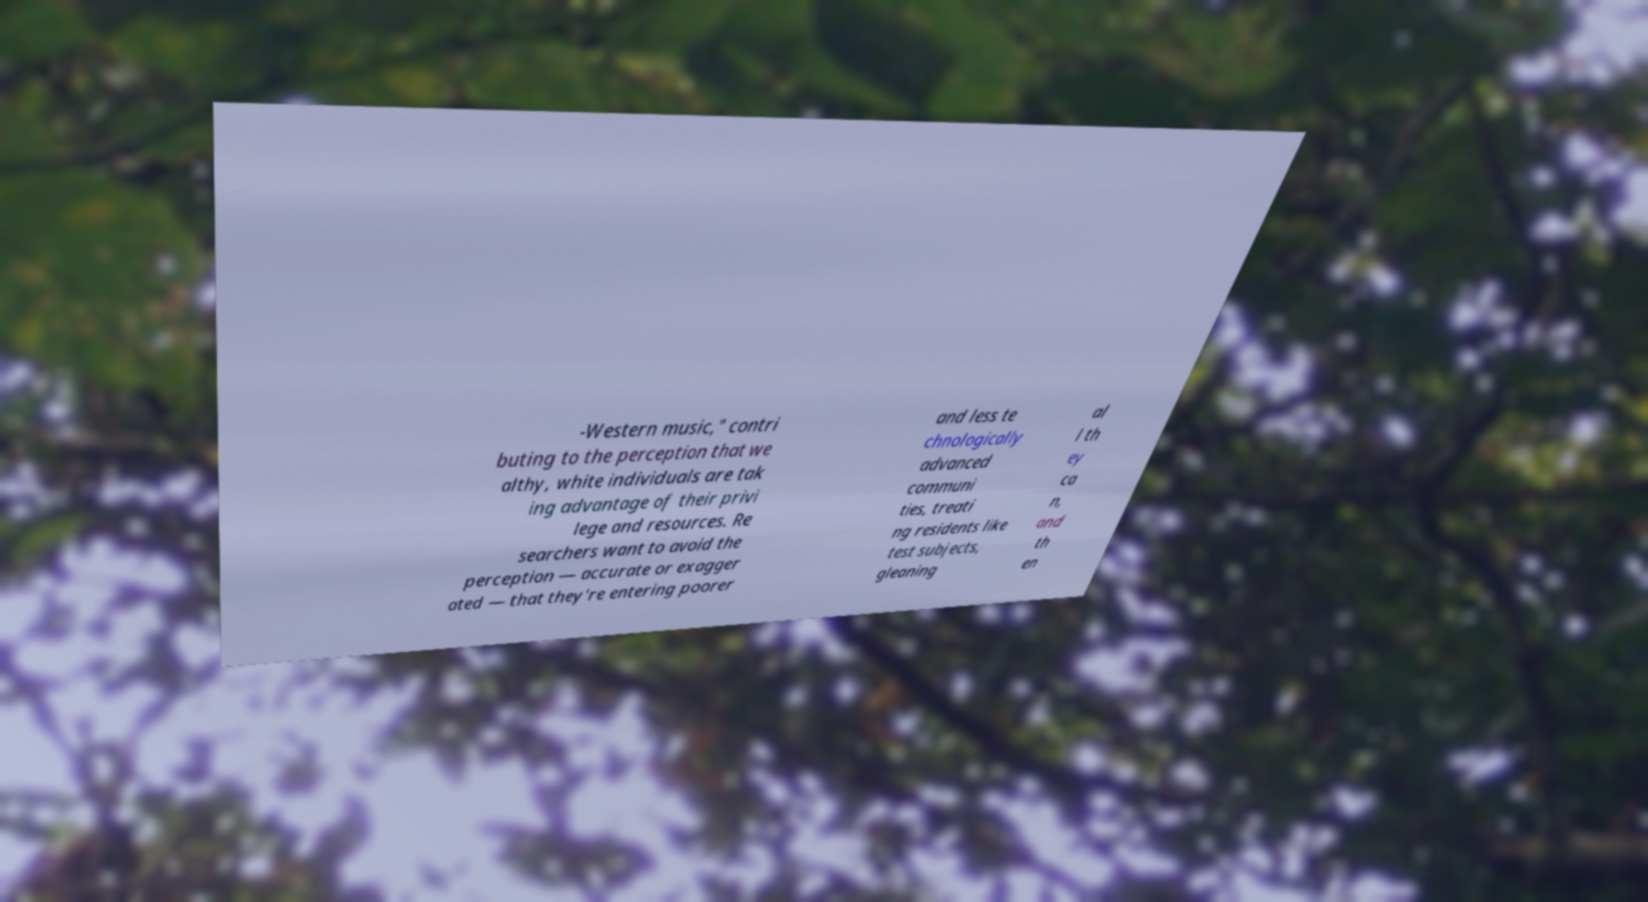There's text embedded in this image that I need extracted. Can you transcribe it verbatim? -Western music," contri buting to the perception that we althy, white individuals are tak ing advantage of their privi lege and resources. Re searchers want to avoid the perception — accurate or exagger ated — that they're entering poorer and less te chnologically advanced communi ties, treati ng residents like test subjects, gleaning al l th ey ca n, and th en 